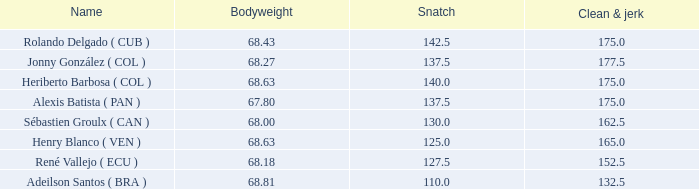Tell me the highest snatch for 68.63 bodyweight and total kg less than 290 None. 